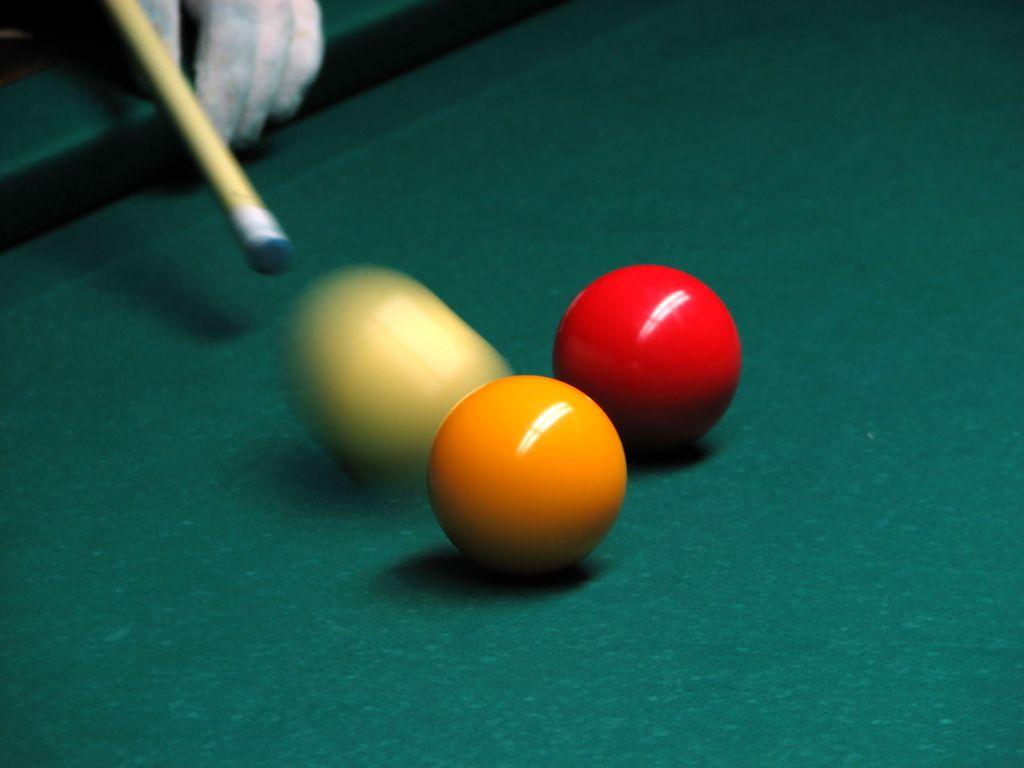What is the color of the surface in the image? There is a green surface in the image. What objects are placed on the green surface? There are three balls on the green surface. What are the colors of the balls? The balls are of cream, yellow, and red colors. What else can be seen in the image besides the balls? There is a stick and a person's hand visible in the image. What is the order of the balls on the green surface? There is no specific order mentioned for the balls on the green surface. --- 